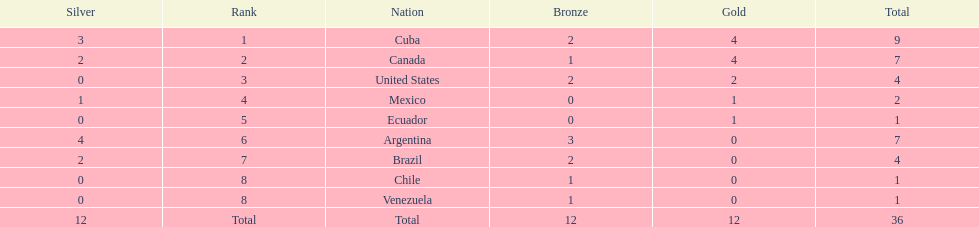What were all of the nations involved in the canoeing at the 2011 pan american games? Cuba, Canada, United States, Mexico, Ecuador, Argentina, Brazil, Chile, Venezuela, Total. Of these, which had a numbered rank? Cuba, Canada, United States, Mexico, Ecuador, Argentina, Brazil, Chile, Venezuela. From these, which had the highest number of bronze? Argentina. 